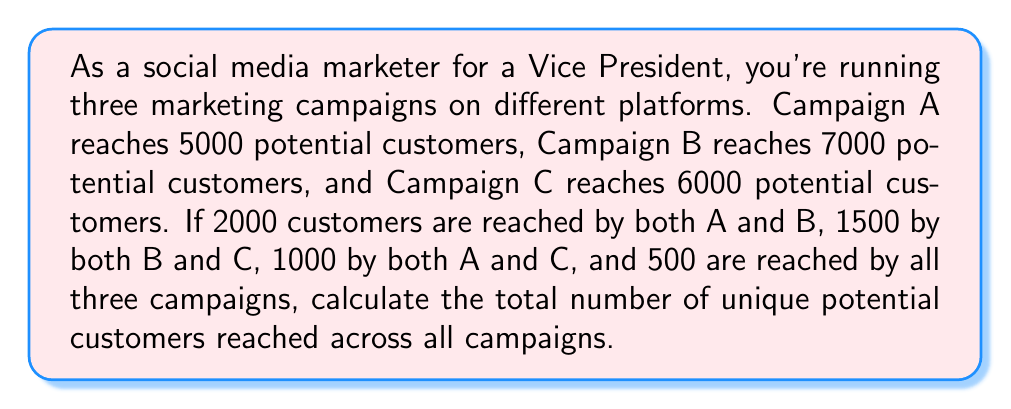Can you answer this question? To solve this problem, we'll use the principle of inclusion-exclusion for three sets. Let's define our sets:

$A$ = potential customers reached by Campaign A
$B$ = potential customers reached by Campaign B
$C$ = potential customers reached by Campaign C

We're given:
$|A| = 5000$
$|B| = 7000$
$|C| = 6000$
$|A \cap B| = 2000$
$|B \cap C| = 1500$
$|A \cap C| = 1000$
$|A \cap B \cap C| = 500$

The formula for the union of three sets is:

$$|A \cup B \cup C| = |A| + |B| + |C| - |A \cap B| - |B \cap C| - |A \cap C| + |A \cap B \cap C|$$

Let's substitute our values:

$$|A \cup B \cup C| = 5000 + 7000 + 6000 - 2000 - 1500 - 1000 + 500$$

Now we can calculate:

$$|A \cup B \cup C| = 18000 - 4500 + 500 = 14000$$

Therefore, the total number of unique potential customers reached across all campaigns is 14,000.
Answer: 14,000 unique potential customers 